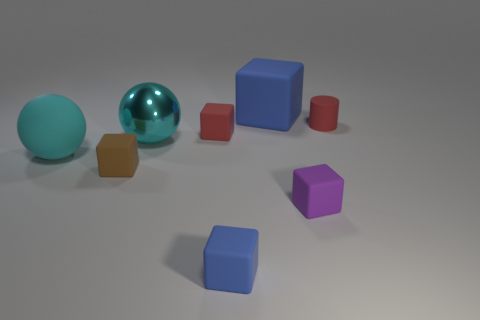There is a tiny object that is the same color as the matte cylinder; what is its material?
Your response must be concise. Rubber. Is the number of big cyan metallic things greater than the number of large yellow shiny blocks?
Make the answer very short. Yes. Do the brown cube and the cyan matte object have the same size?
Offer a very short reply. No. What number of things are blue objects or small brown cubes?
Provide a short and direct response. 3. There is a tiny purple object right of the blue thing in front of the blue matte object behind the tiny blue object; what is its shape?
Your answer should be compact. Cube. Is the cyan sphere that is to the left of the large cyan shiny object made of the same material as the blue thing that is in front of the big rubber cube?
Ensure brevity in your answer.  Yes. There is a small purple thing that is the same shape as the small brown thing; what is its material?
Offer a very short reply. Rubber. Is there any other thing that has the same size as the brown object?
Make the answer very short. Yes. Does the large thing that is left of the brown thing have the same shape as the big object that is to the right of the tiny blue rubber object?
Provide a short and direct response. No. Are there fewer brown rubber cubes to the right of the purple block than big spheres that are to the right of the large blue thing?
Provide a succinct answer. No. 